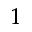<formula> <loc_0><loc_0><loc_500><loc_500>^ { 1 }</formula> 